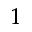<formula> <loc_0><loc_0><loc_500><loc_500>^ { 1 }</formula> 